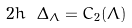<formula> <loc_0><loc_0><loc_500><loc_500>2 h \ \Delta _ { \Lambda } = C _ { 2 } ( \Lambda ) \</formula> 